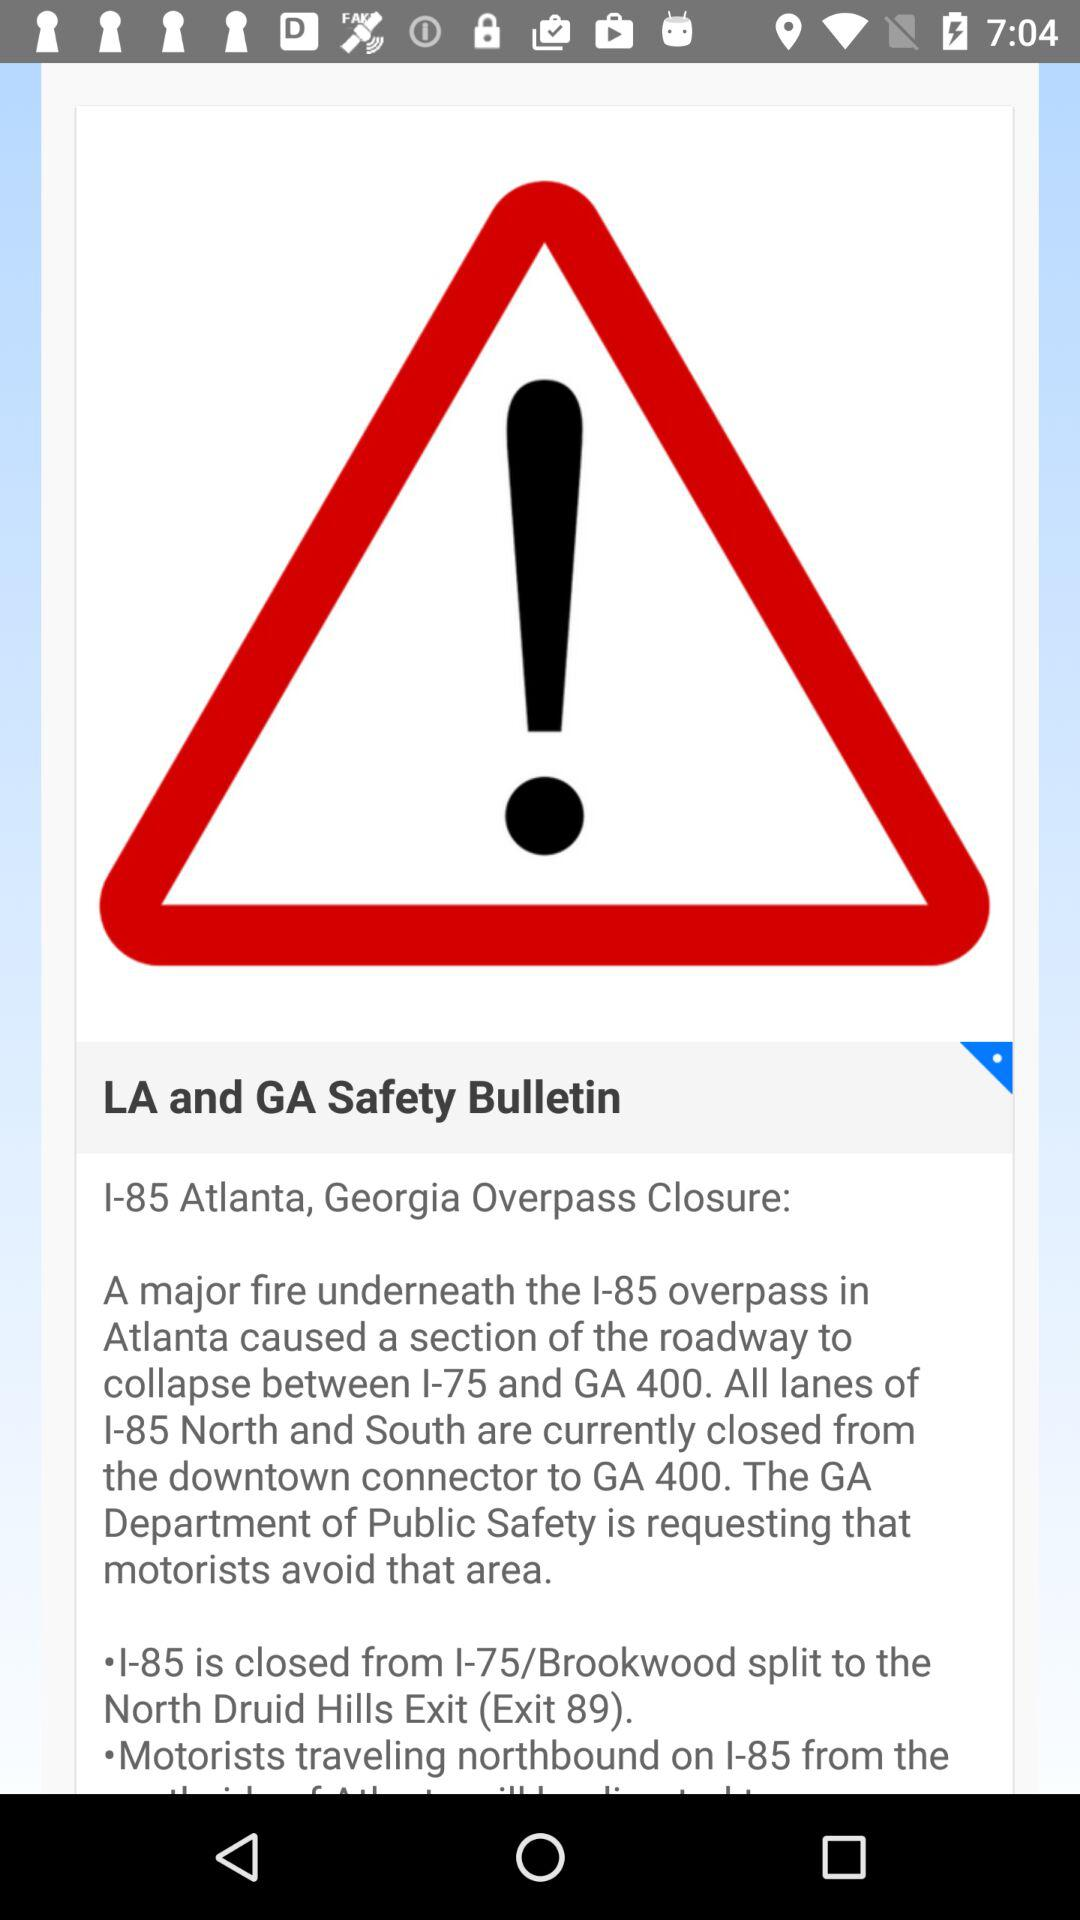How many lanes of I-85 are closed?
Answer the question using a single word or phrase. All lanes 